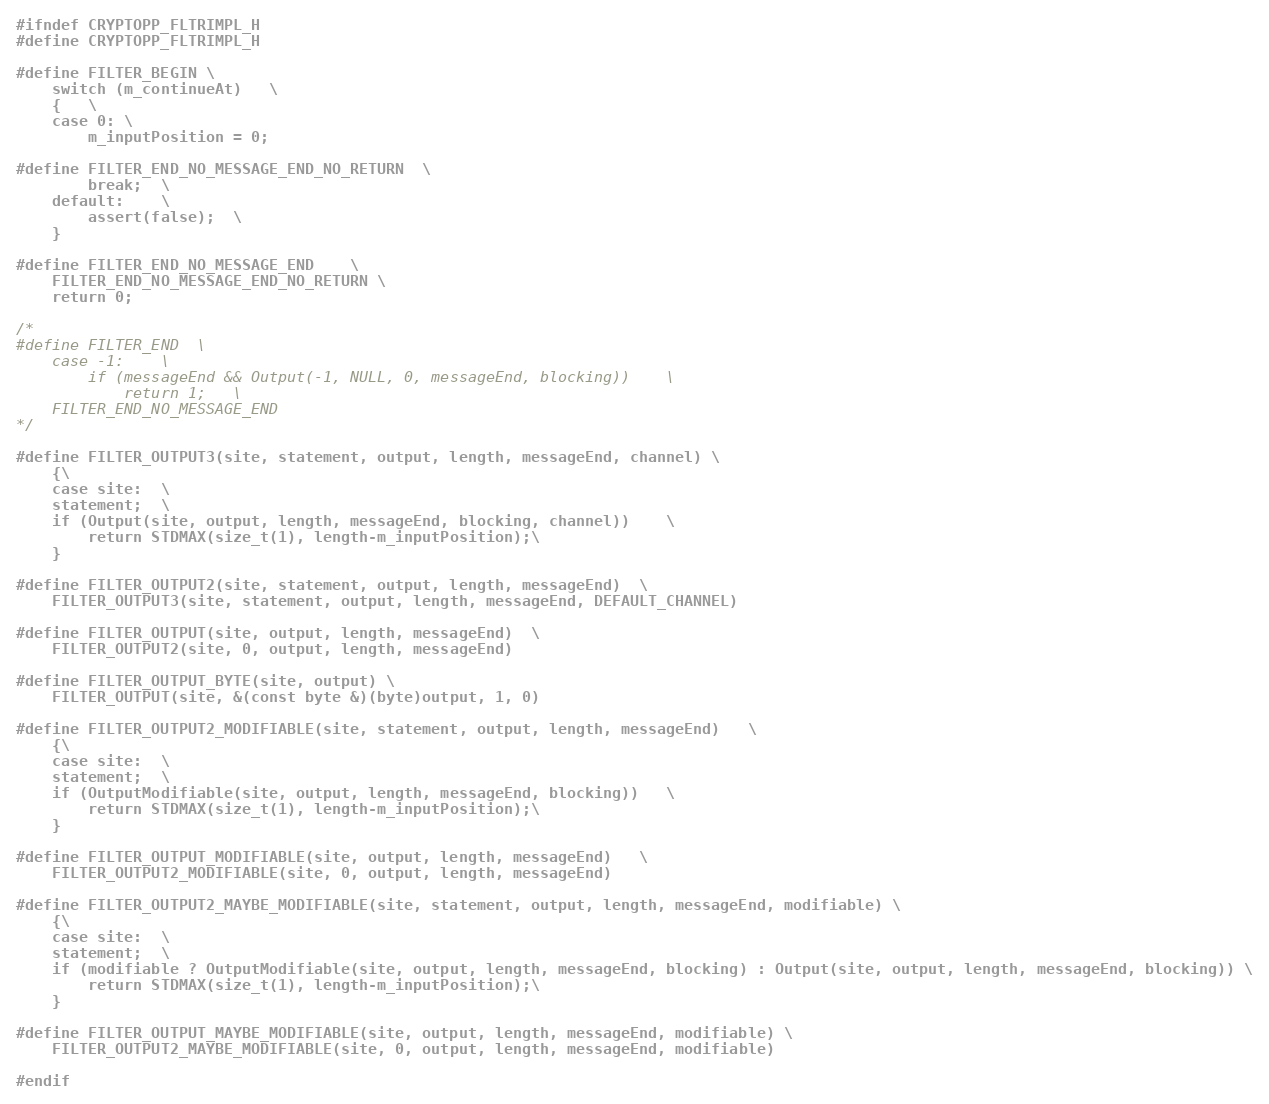Convert code to text. <code><loc_0><loc_0><loc_500><loc_500><_C_>#ifndef CRYPTOPP_FLTRIMPL_H
#define CRYPTOPP_FLTRIMPL_H

#define FILTER_BEGIN	\
	switch (m_continueAt)	\
	{	\
	case 0:	\
		m_inputPosition = 0;

#define FILTER_END_NO_MESSAGE_END_NO_RETURN	\
		break;	\
	default:	\
		assert(false);	\
	}

#define FILTER_END_NO_MESSAGE_END	\
	FILTER_END_NO_MESSAGE_END_NO_RETURN	\
	return 0;

/*
#define FILTER_END	\
	case -1:	\
		if (messageEnd && Output(-1, NULL, 0, messageEnd, blocking))	\
			return 1;	\
	FILTER_END_NO_MESSAGE_END
*/

#define FILTER_OUTPUT3(site, statement, output, length, messageEnd, channel)	\
	{\
	case site:	\
	statement;	\
	if (Output(site, output, length, messageEnd, blocking, channel))	\
		return STDMAX(size_t(1), length-m_inputPosition);\
	}

#define FILTER_OUTPUT2(site, statement, output, length, messageEnd)	\
	FILTER_OUTPUT3(site, statement, output, length, messageEnd, DEFAULT_CHANNEL)

#define FILTER_OUTPUT(site, output, length, messageEnd)	\
	FILTER_OUTPUT2(site, 0, output, length, messageEnd)

#define FILTER_OUTPUT_BYTE(site, output)	\
	FILTER_OUTPUT(site, &(const byte &)(byte)output, 1, 0)

#define FILTER_OUTPUT2_MODIFIABLE(site, statement, output, length, messageEnd)	\
	{\
	case site:	\
	statement;	\
	if (OutputModifiable(site, output, length, messageEnd, blocking))	\
		return STDMAX(size_t(1), length-m_inputPosition);\
	}

#define FILTER_OUTPUT_MODIFIABLE(site, output, length, messageEnd)	\
	FILTER_OUTPUT2_MODIFIABLE(site, 0, output, length, messageEnd)

#define FILTER_OUTPUT2_MAYBE_MODIFIABLE(site, statement, output, length, messageEnd, modifiable)	\
	{\
	case site:	\
	statement;	\
	if (modifiable ? OutputModifiable(site, output, length, messageEnd, blocking) : Output(site, output, length, messageEnd, blocking))	\
		return STDMAX(size_t(1), length-m_inputPosition);\
	}

#define FILTER_OUTPUT_MAYBE_MODIFIABLE(site, output, length, messageEnd, modifiable)	\
	FILTER_OUTPUT2_MAYBE_MODIFIABLE(site, 0, output, length, messageEnd, modifiable)

#endif
</code> 